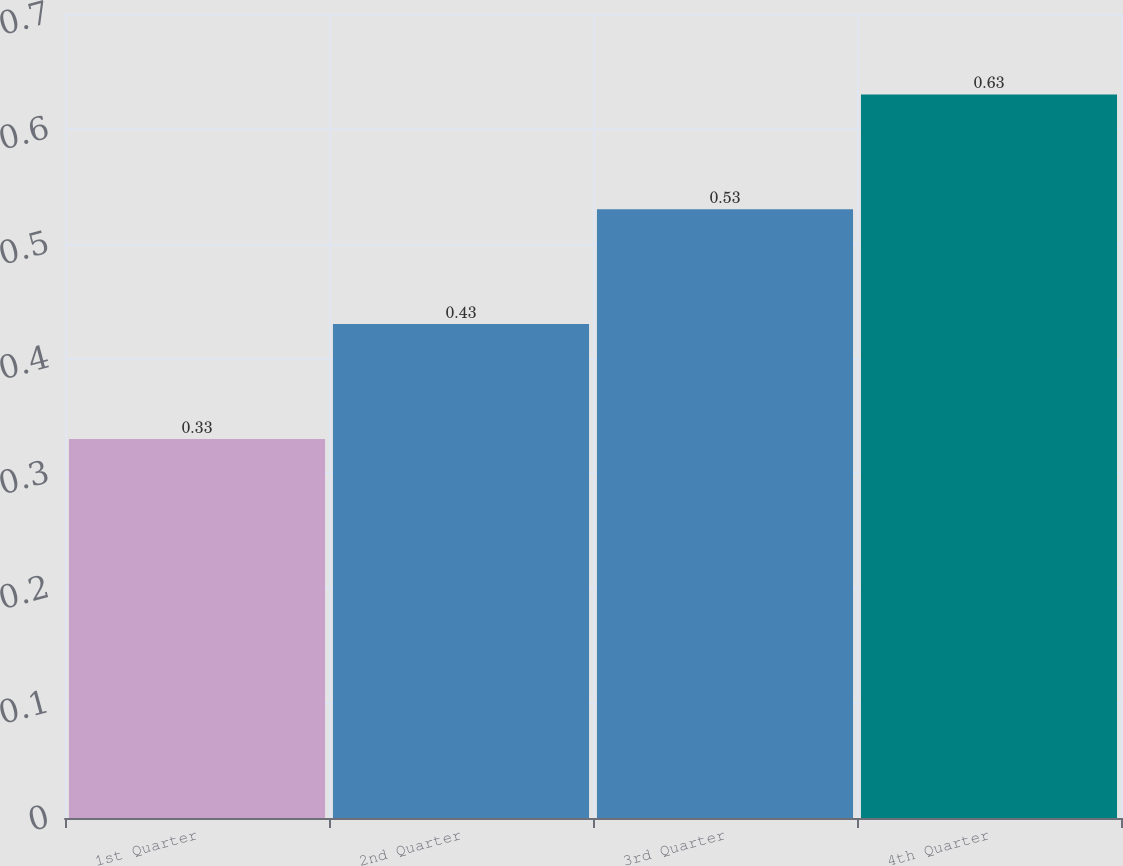Convert chart. <chart><loc_0><loc_0><loc_500><loc_500><bar_chart><fcel>1st Quarter<fcel>2nd Quarter<fcel>3rd Quarter<fcel>4th Quarter<nl><fcel>0.33<fcel>0.43<fcel>0.53<fcel>0.63<nl></chart> 